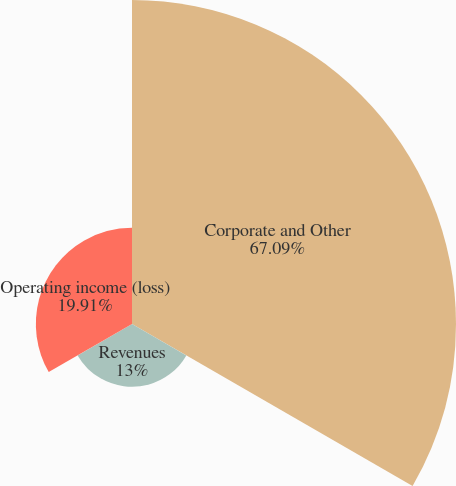Convert chart. <chart><loc_0><loc_0><loc_500><loc_500><pie_chart><fcel>Corporate and Other<fcel>Revenues<fcel>Operating income (loss)<nl><fcel>67.09%<fcel>13.0%<fcel>19.91%<nl></chart> 